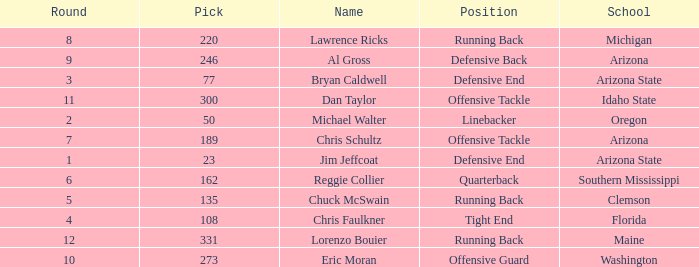What is the position of the player for Washington school? Offensive Guard. 